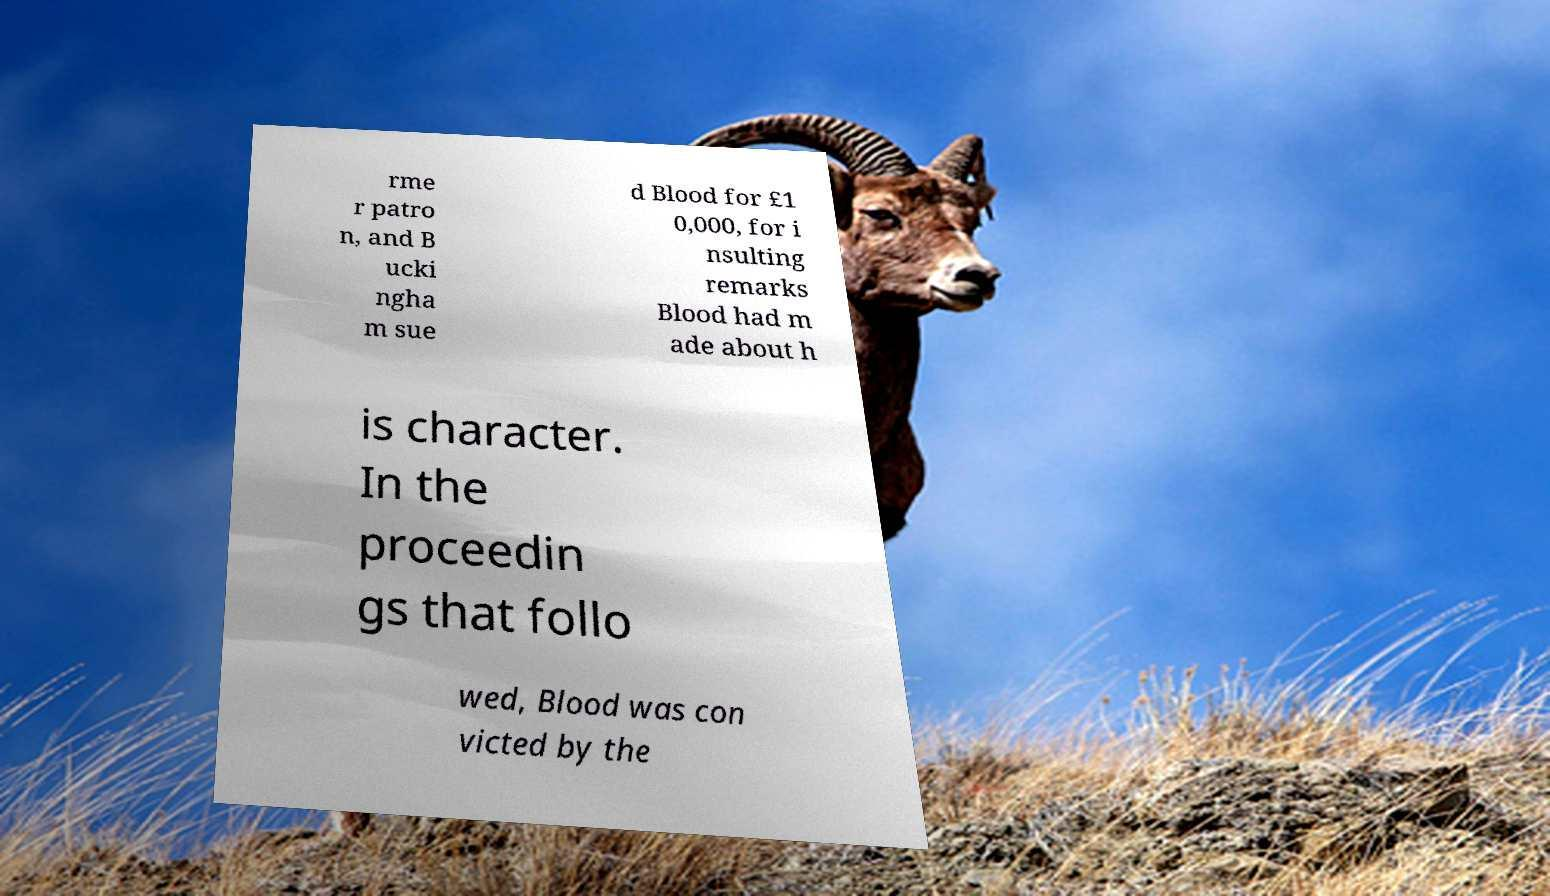Please identify and transcribe the text found in this image. rme r patro n, and B ucki ngha m sue d Blood for £1 0,000, for i nsulting remarks Blood had m ade about h is character. In the proceedin gs that follo wed, Blood was con victed by the 